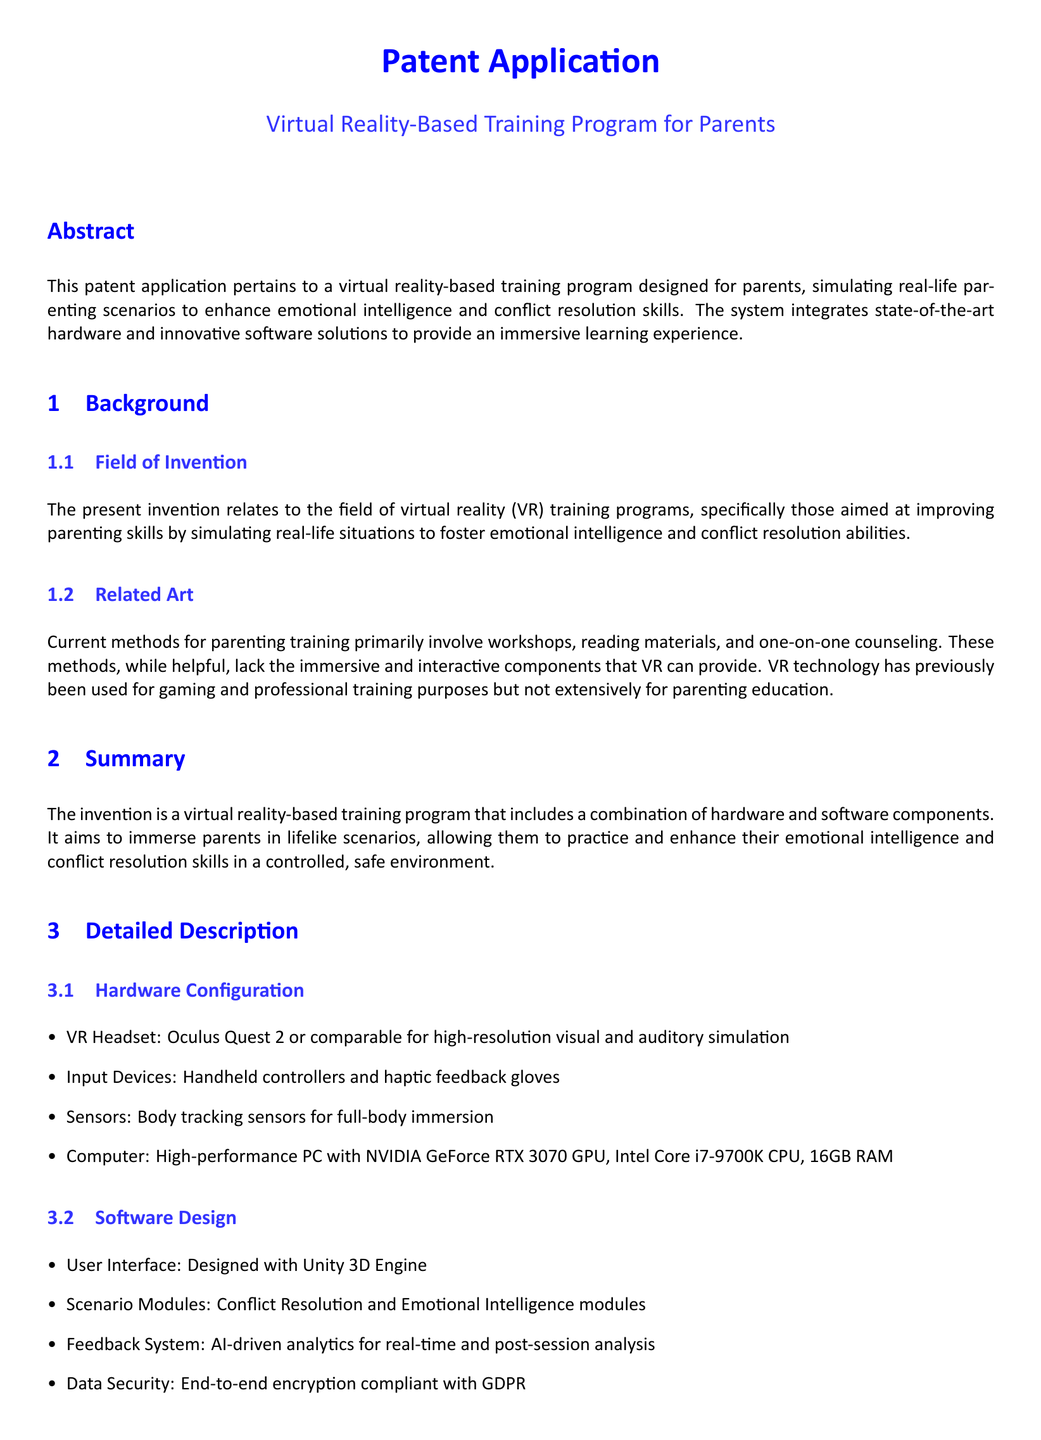What is the main focus of the patent application? The main focus is a virtual reality-based training program for parents.
Answer: virtual reality-based training program for parents What is the primary goal of the system? The primary goal is to enhance emotional intelligence and conflict resolution skills.
Answer: enhance emotional intelligence and conflict resolution skills What hardware is used for high-resolution visual simulation? The hardware used is Oculus Quest 2 or comparable.
Answer: Oculus Quest 2 How much RAM is required for the computer? The computer requires 16GB RAM.
Answer: 16GB RAM What technology does the software utilize for user interface design? The software utilizes Unity 3D Engine for user interface design.
Answer: Unity 3D Engine What type of feedback system is incorporated in the software? The feedback system is AI-driven analytics.
Answer: AI-driven analytics What does the system simulate? The system simulates real-life parenting scenarios.
Answer: real-life parenting scenarios What compliance does the data security feature adhere to? The data security feature is compliant with GDPR.
Answer: GDPR How many claims are included in the document? There are three claims included in the document.
Answer: three claims What is the field of invention mentioned? The field of invention is virtual reality (VR) training programs.
Answer: virtual reality (VR) training programs 